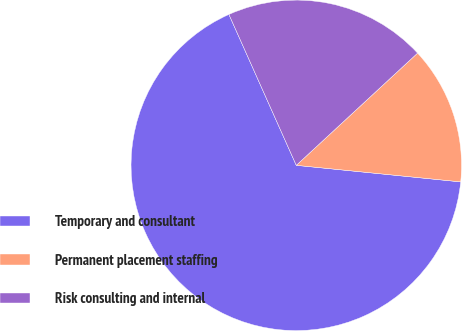<chart> <loc_0><loc_0><loc_500><loc_500><pie_chart><fcel>Temporary and consultant<fcel>Permanent placement staffing<fcel>Risk consulting and internal<nl><fcel>66.72%<fcel>13.48%<fcel>19.8%<nl></chart> 